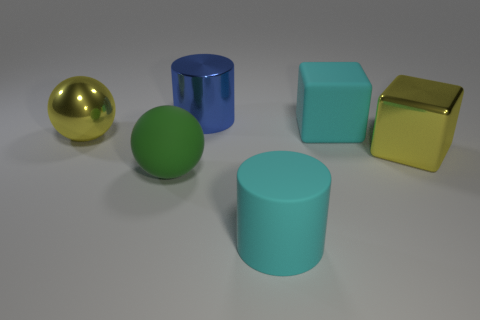Subtract all purple cylinders. Subtract all red cubes. How many cylinders are left? 2 Add 4 blocks. How many objects exist? 10 Subtract all cylinders. How many objects are left? 4 Add 1 large matte cylinders. How many large matte cylinders are left? 2 Add 1 green spheres. How many green spheres exist? 2 Subtract 1 cyan cylinders. How many objects are left? 5 Subtract all large green balls. Subtract all tiny purple metallic spheres. How many objects are left? 5 